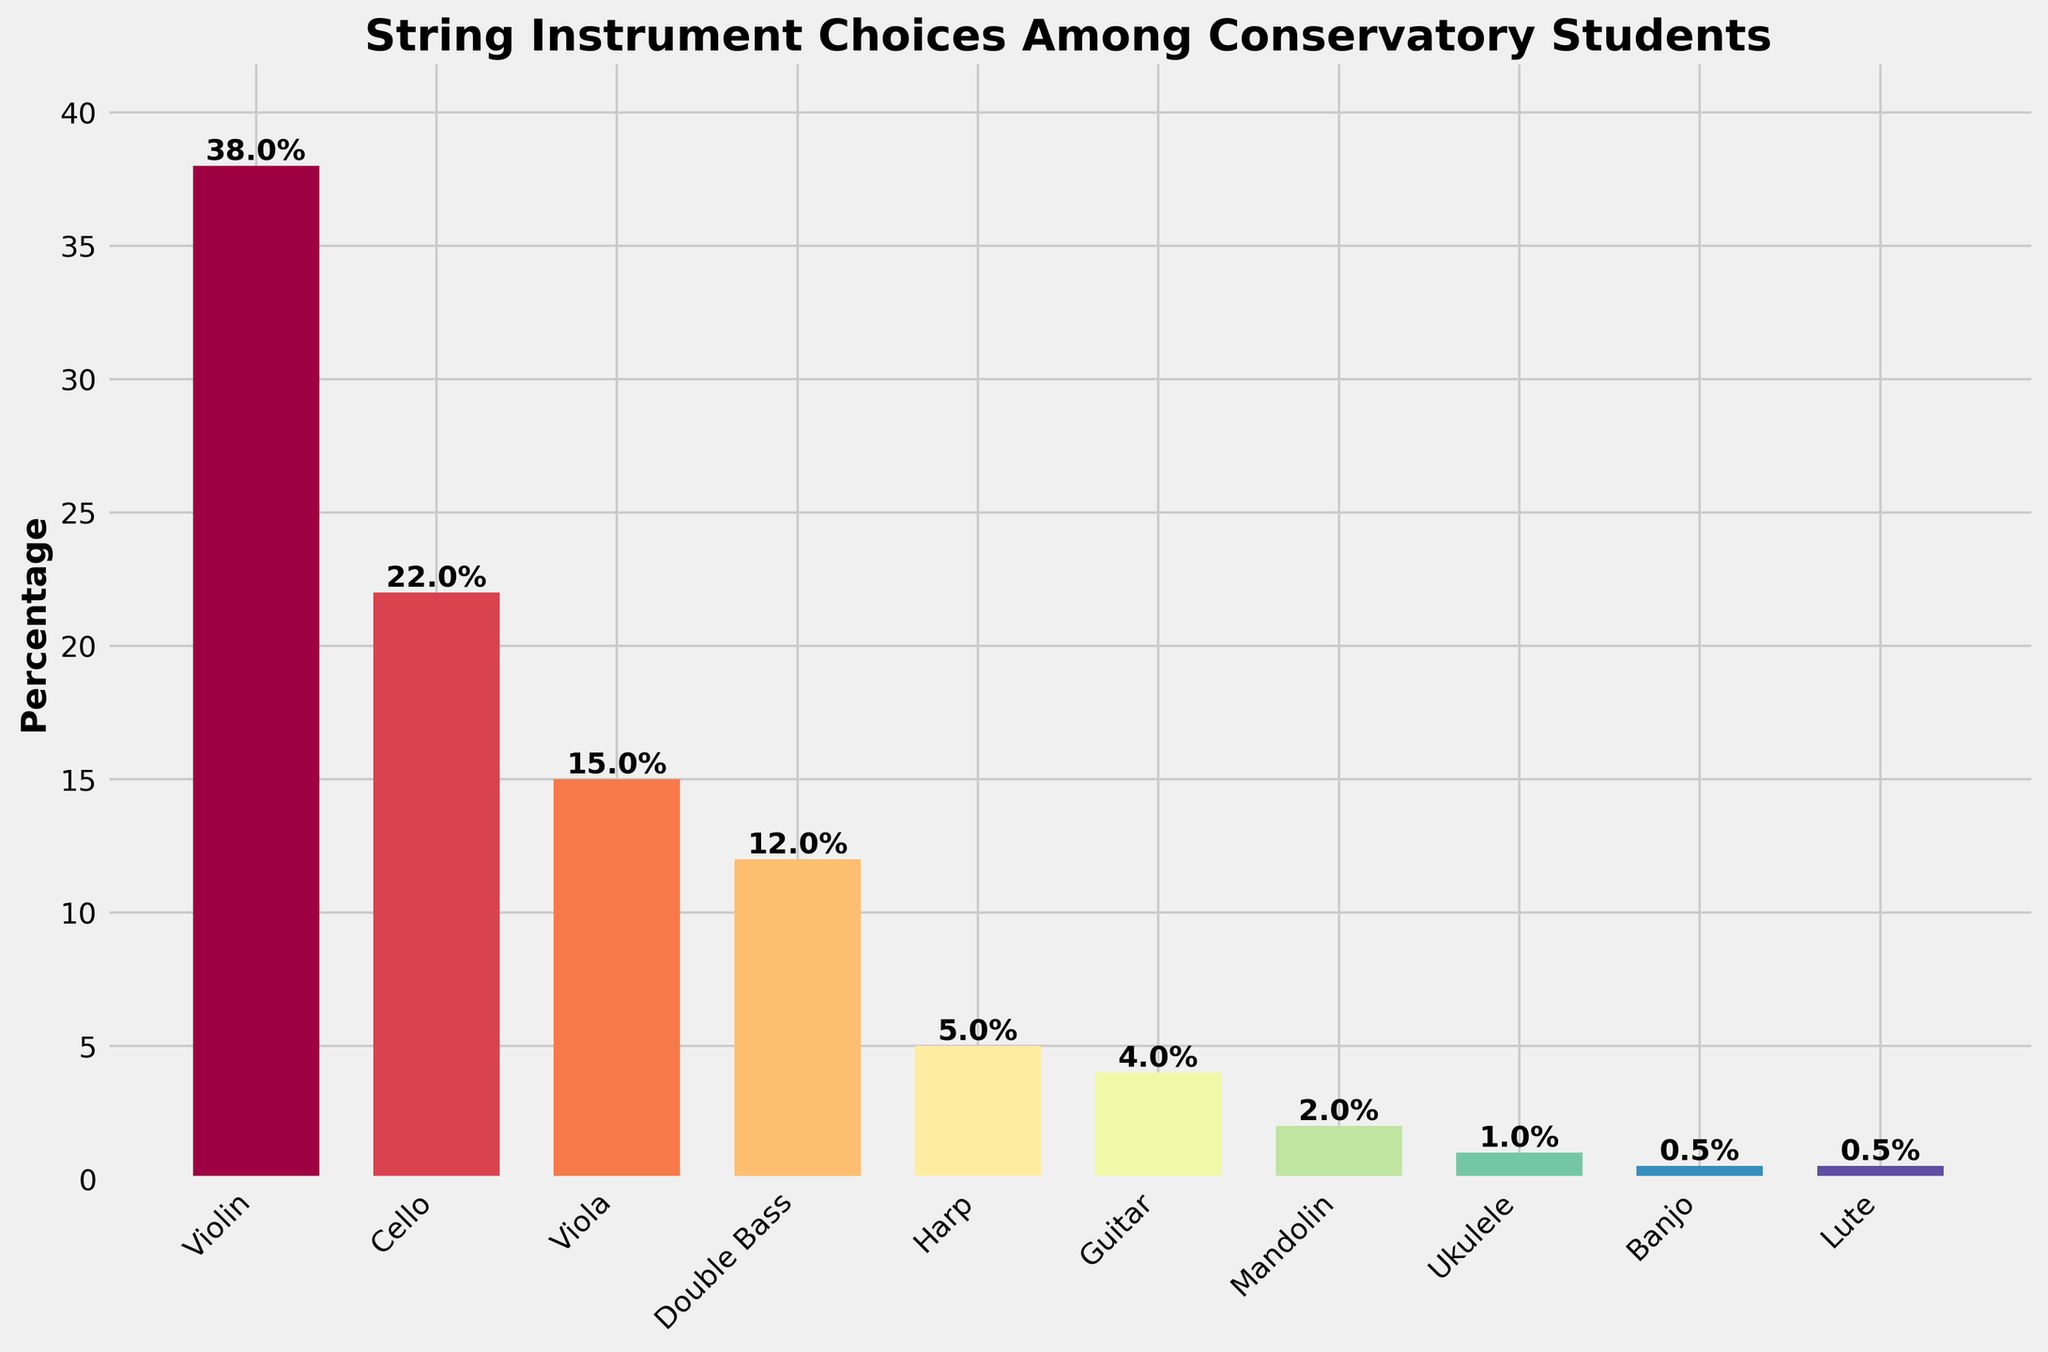Which instrument has the highest percentage of choices among conservatory students? The instrument with the highest bar (tallest) represents the highest percentage of choices. In this figure, the Violin has the tallest bar, indicating 38%.
Answer: Violin What's the combined percentage of students choosing either the Banjo or the Lute? Add the percentages for Banjo and Lute. Banjo has 0.5% and Lute also has 0.5%. So, 0.5% + 0.5% = 1%.
Answer: 1% How much more popular is the Violin compared to the Ukulele? Subtract the percentage for Ukulele from the percentage for Violin. Violin has 38% and Ukulele has 1%. So, 38% - 1% = 37%.
Answer: 37% Which two instruments have the closest percentage of choices? By comparing the heights of the bars visually or by percentage values, notice that Banjo and Lute have the same percentage of 0.5%.
Answer: Banjo and Lute How many instruments have a percentage of choices greater than 10%? Count the number of bars that are taller than the bar representing 10%. The instruments Violin (38%), Cello (22%), Viola (15%), and Double Bass (12%) have percentages greater than 10%. So, there are 4 such instruments.
Answer: 4 What is the percentage range of instrument choices among students? To find the range, subtract the smallest percentage from the largest percentage. The largest percentage is for Violin (38%) and the smallest is for Banjo or Lute (0.5%). So, 38% - 0.5% = 37.5%.
Answer: 37.5% What is the least chosen instrument category? Identify the instrument with the smallest bar (shortest height). Both Banjo and Lute are tied with the smallest percentages of 0.5%.
Answer: Banjo and Lute Which instrument category falls directly in the middle in terms of popularity? Arrange the instruments by percentage in ascending order and find the middle value. Given the total number of instruments (10), the median would be the 5th and 6th values combined and averaged. Guitar (4%) and Harp (5%) are these values, and the middle (thus, average) percentage is (4% + 5%)/2 = 4.5%, but specifically, Harp has the 5th highest on its own at 5%.
Answer: Harp 